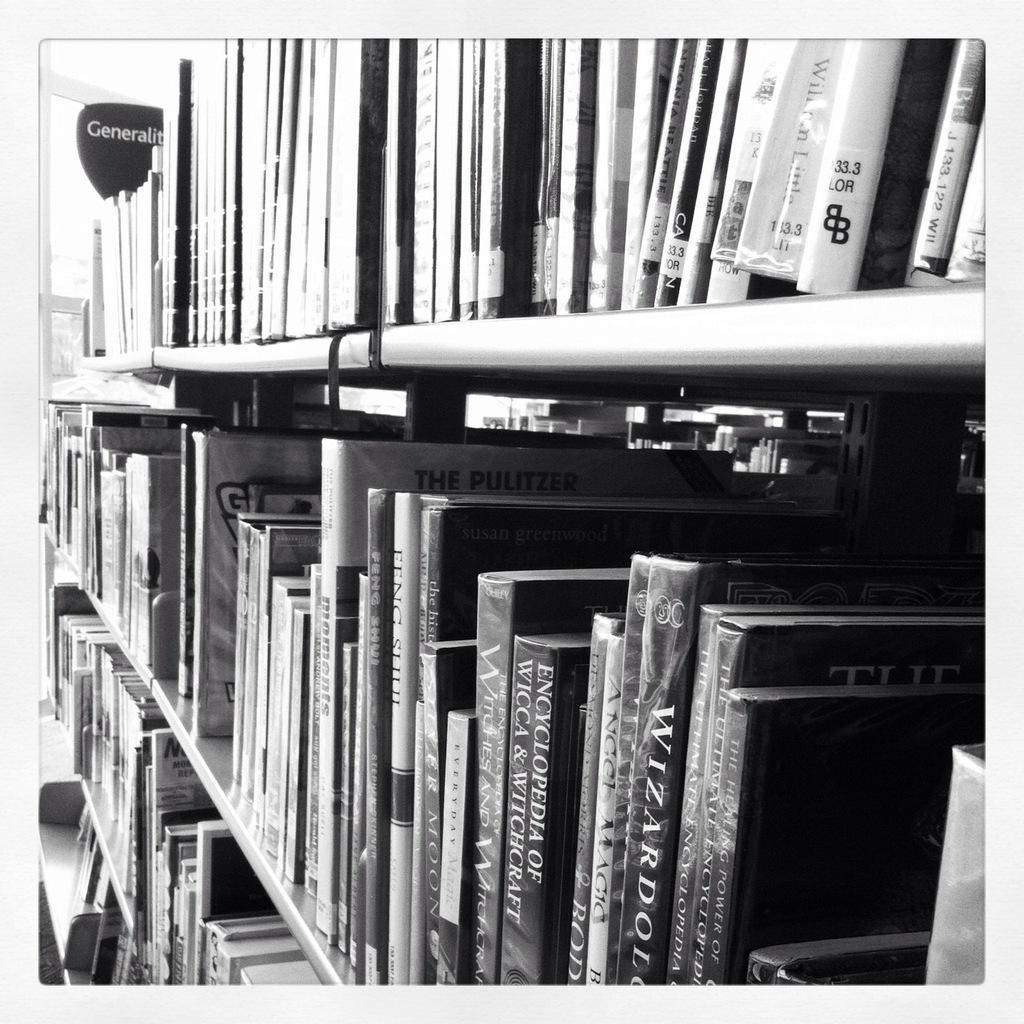What is the main object in the center of the image? There is a bookshelf in the center of the image. What is stored on the bookshelf? The bookshelf contains books. What month is depicted on the bookshelf in the image? There is no month depicted on the bookshelf in the image; it contains books. What emotion is the bookshelf expressing in the image? The bookshelf is an inanimate object and does not express emotions. 